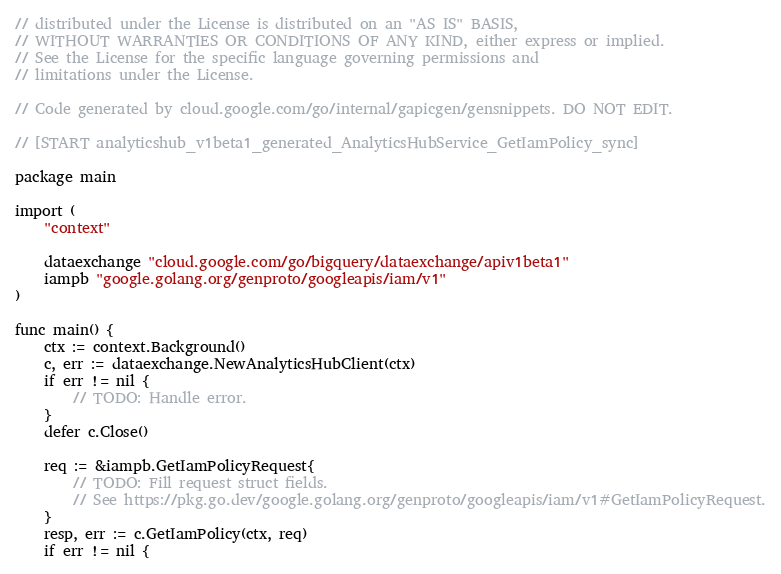<code> <loc_0><loc_0><loc_500><loc_500><_Go_>// distributed under the License is distributed on an "AS IS" BASIS,
// WITHOUT WARRANTIES OR CONDITIONS OF ANY KIND, either express or implied.
// See the License for the specific language governing permissions and
// limitations under the License.

// Code generated by cloud.google.com/go/internal/gapicgen/gensnippets. DO NOT EDIT.

// [START analyticshub_v1beta1_generated_AnalyticsHubService_GetIamPolicy_sync]

package main

import (
	"context"

	dataexchange "cloud.google.com/go/bigquery/dataexchange/apiv1beta1"
	iampb "google.golang.org/genproto/googleapis/iam/v1"
)

func main() {
	ctx := context.Background()
	c, err := dataexchange.NewAnalyticsHubClient(ctx)
	if err != nil {
		// TODO: Handle error.
	}
	defer c.Close()

	req := &iampb.GetIamPolicyRequest{
		// TODO: Fill request struct fields.
		// See https://pkg.go.dev/google.golang.org/genproto/googleapis/iam/v1#GetIamPolicyRequest.
	}
	resp, err := c.GetIamPolicy(ctx, req)
	if err != nil {</code> 